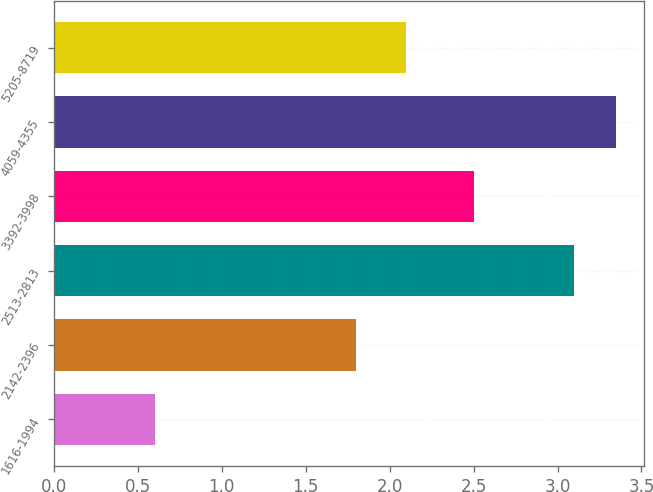Convert chart. <chart><loc_0><loc_0><loc_500><loc_500><bar_chart><fcel>1616-1994<fcel>2142-2396<fcel>2513-2813<fcel>3392-3998<fcel>4059-4355<fcel>5205-8719<nl><fcel>0.6<fcel>1.8<fcel>3.1<fcel>2.5<fcel>3.35<fcel>2.1<nl></chart> 